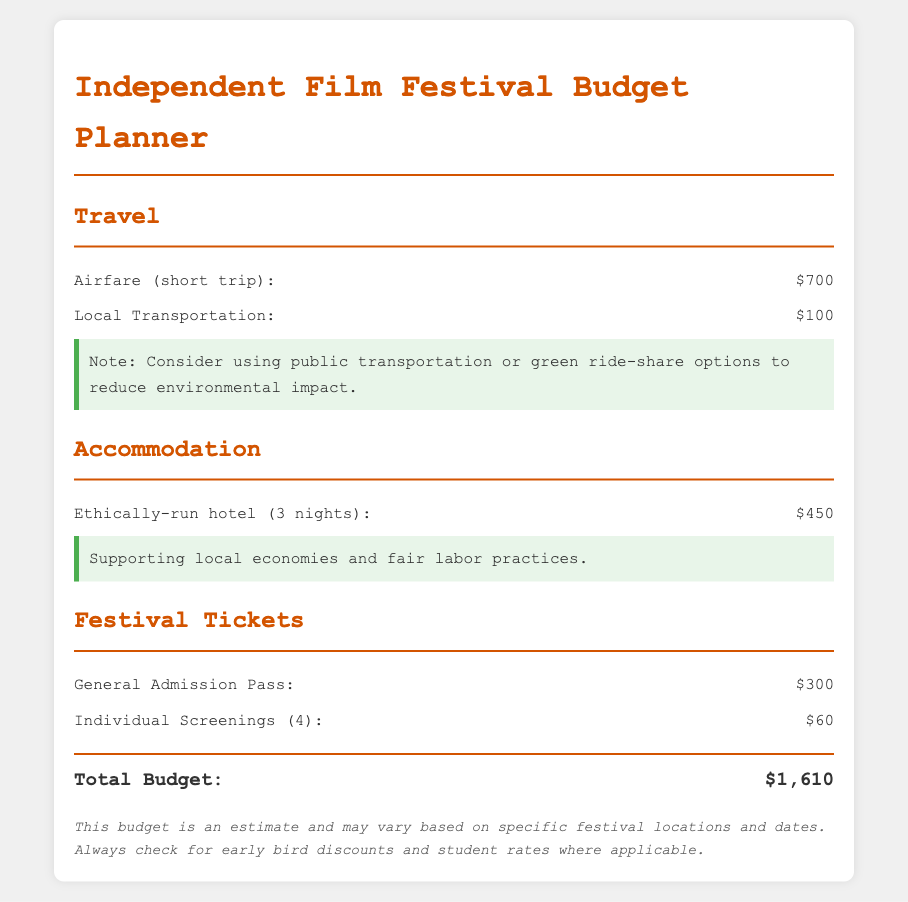What is the total budget? The total budget is listed under the total section of the document, which sums up all costs.
Answer: $1,610 How much does the airfare cost? The airfare cost is specified in the travel section of the document.
Answer: $700 What is the cost for local transportation? The cost for local transportation is also found in the travel section of the document.
Answer: $100 How much is the general admission pass? The cost of the general admission pass is provided in the festival tickets section.
Answer: $300 How many individual screenings are included? The number of individual screenings is mentioned in the festival tickets section.
Answer: 4 What is the cost of accommodation for three nights? The accommodation cost is specified in the accommodation section of the document.
Answer: $450 What ethical considerations are suggested for transportation? The document notes the importance of considering eco-friendly options for transportation.
Answer: Public transportation or green ride-share What is the significance of staying at an ethically-run hotel? The document mentions supporting local economies and fair labor practices as a reason.
Answer: Supporting local economies and fair labor practices What is the price for individual screenings? The price for individual screenings is detailed in the festival tickets section.
Answer: $60 